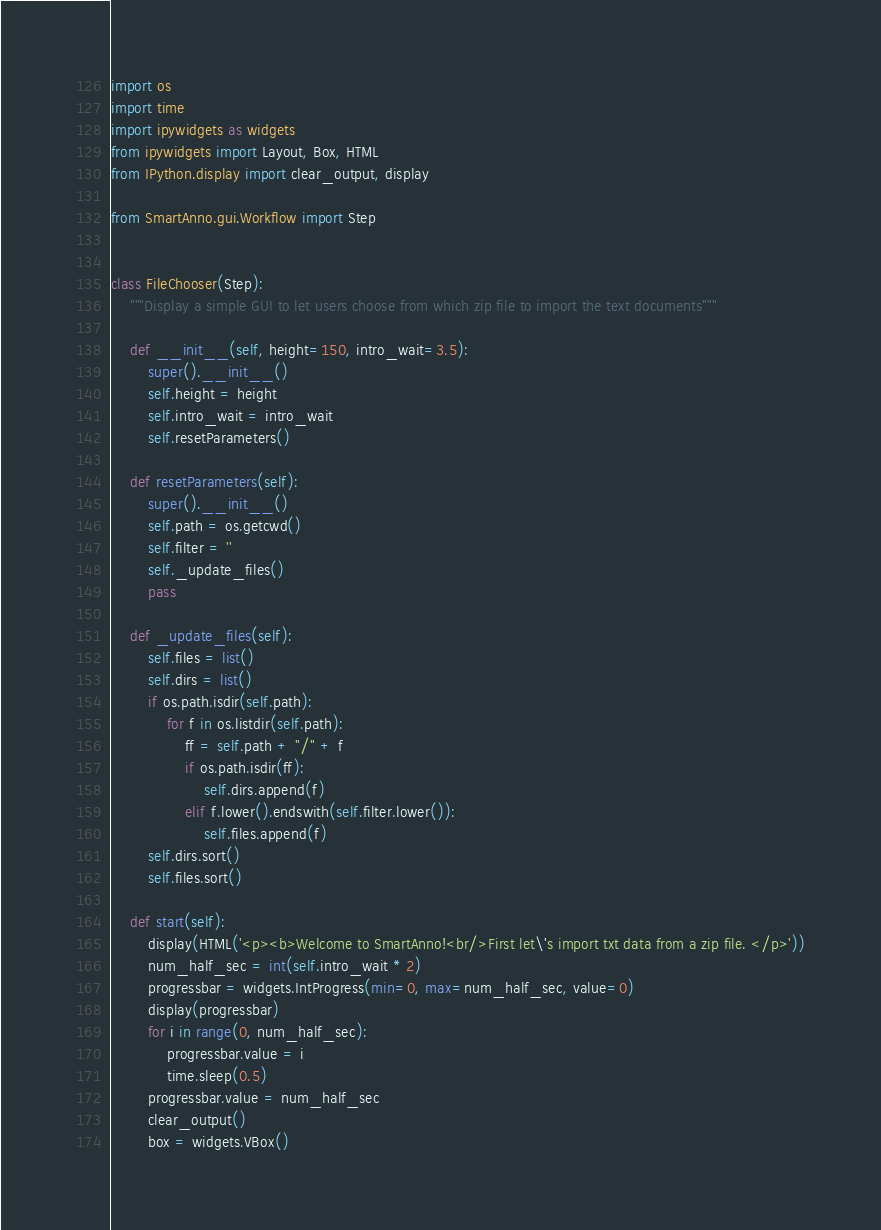Convert code to text. <code><loc_0><loc_0><loc_500><loc_500><_Python_>import os
import time
import ipywidgets as widgets
from ipywidgets import Layout, Box, HTML
from IPython.display import clear_output, display

from SmartAnno.gui.Workflow import Step


class FileChooser(Step):
    """Display a simple GUI to let users choose from which zip file to import the text documents"""

    def __init__(self, height=150, intro_wait=3.5):
        super().__init__()
        self.height = height
        self.intro_wait = intro_wait
        self.resetParameters()

    def resetParameters(self):
        super().__init__()
        self.path = os.getcwd()
        self.filter = ''
        self._update_files()
        pass

    def _update_files(self):
        self.files = list()
        self.dirs = list()
        if os.path.isdir(self.path):
            for f in os.listdir(self.path):
                ff = self.path + "/" + f
                if os.path.isdir(ff):
                    self.dirs.append(f)
                elif f.lower().endswith(self.filter.lower()):
                    self.files.append(f)
        self.dirs.sort()
        self.files.sort()

    def start(self):
        display(HTML('<p><b>Welcome to SmartAnno!<br/>First let\'s import txt data from a zip file. </p>'))
        num_half_sec = int(self.intro_wait * 2)
        progressbar = widgets.IntProgress(min=0, max=num_half_sec, value=0)
        display(progressbar)
        for i in range(0, num_half_sec):
            progressbar.value = i
            time.sleep(0.5)
        progressbar.value = num_half_sec
        clear_output()
        box = widgets.VBox()</code> 